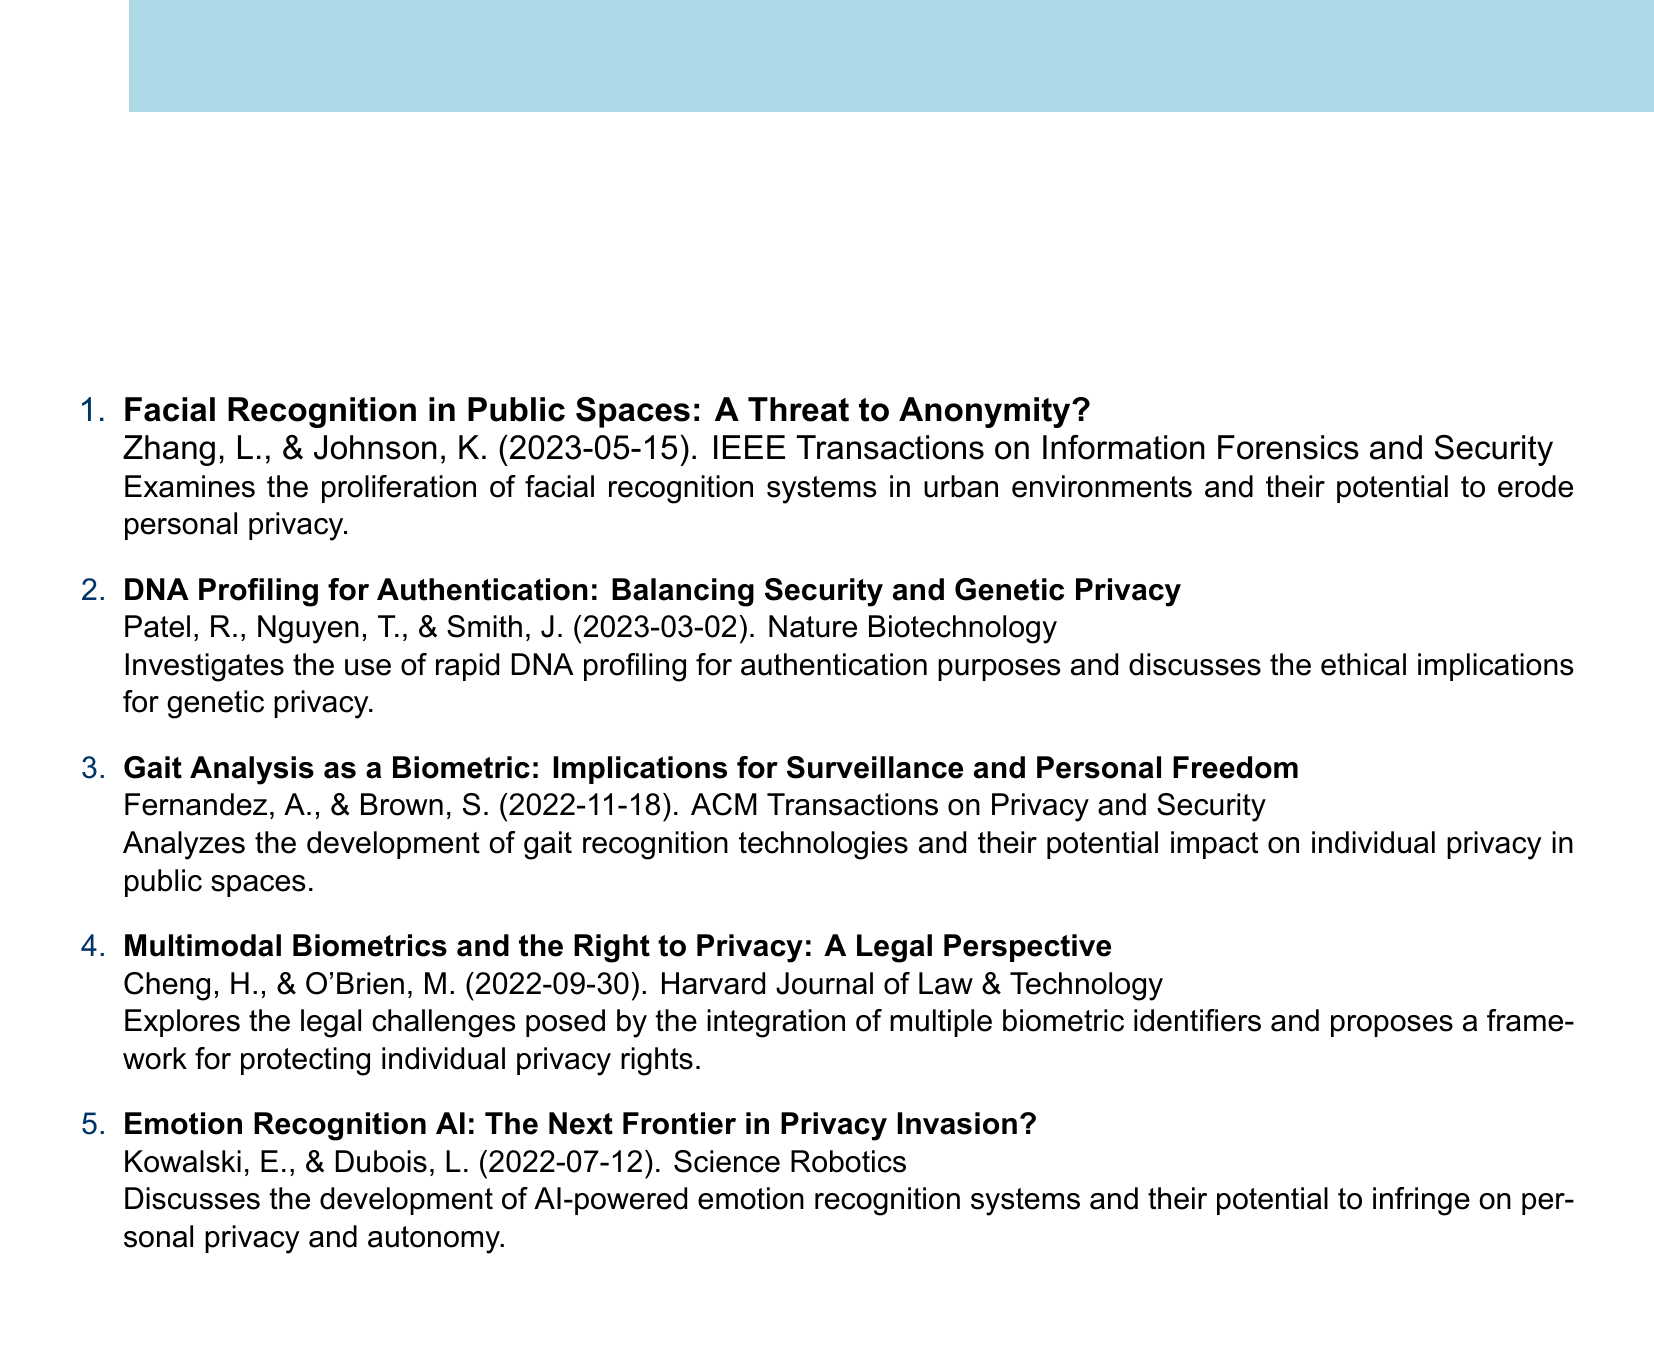What is the title of the first paper? The title is the first line under the numbered entry that describes the research paper and its focus.
Answer: Facial Recognition in Public Spaces: A Threat to Anonymity? Who are the authors of the paper published on 2023-03-02? The authors can be found listed below the title of the paper with the corresponding publication date.
Answer: Patel, R., Nguyen, T., & Smith, J In which journal was the paper on gait analysis published? The journal name is provided below the authors' names and the publication date of the paper.
Answer: ACM Transactions on Privacy and Security What is the publication date of the last paper listed? The publication date is found in parentheses at the end of each entry.
Answer: 2022-07-12 Which biometric technology is discussed in the paper by Kowalski and Dubois? The specific technology can be identified from the title of the paper associated with the authors' names.
Answer: Emotion Recognition AI What ethical aspect does the paper on DNA profiling focus on? The ethical aspect mentioned is the primary concern highlighted in the paper description for understanding its implications.
Answer: Genetic privacy How many papers are included in this catalog? This can be determined by counting the numbered entries in the list.
Answer: 5 